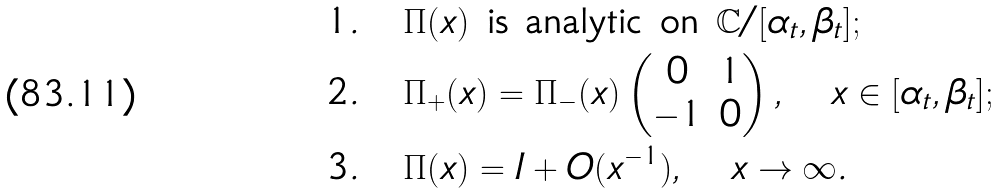Convert formula to latex. <formula><loc_0><loc_0><loc_500><loc_500>& 1 . \quad \text {$\Pi(x)$ is analytic on $\mathbb{C}/[\alpha_{t},\beta_{t}]$} ; \\ & 2 . \quad \Pi _ { + } ( x ) = \Pi _ { - } ( x ) \begin{pmatrix} 0 & 1 \\ - 1 & 0 \end{pmatrix} , \quad x \in [ \alpha _ { t } , \beta _ { t } ] ; \\ & 3 . \quad \Pi ( x ) = I + O ( x ^ { - 1 } ) , \quad x \rightarrow \infty .</formula> 